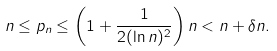Convert formula to latex. <formula><loc_0><loc_0><loc_500><loc_500>n \leq p _ { n } \leq \left ( 1 + \frac { 1 } { 2 ( \ln n ) ^ { 2 } } \right ) n < n + \delta n .</formula> 